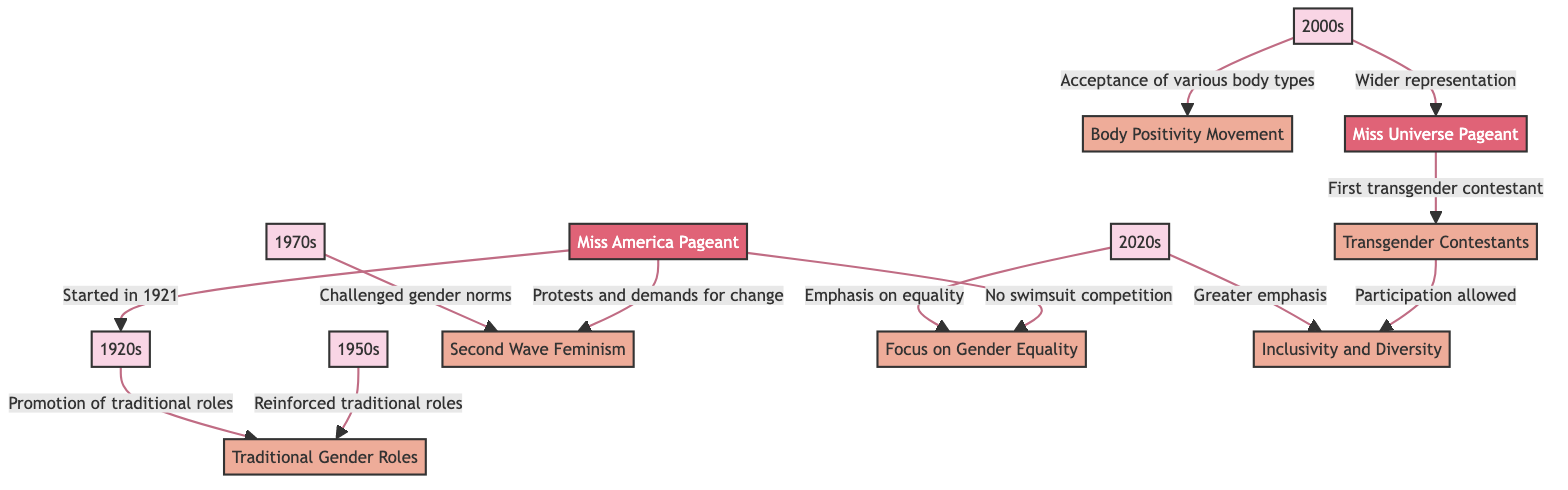What decade began the Miss America Pageant? The diagram indicates that the Miss America Pageant started in the 1920s. Therefore, the answer must refer to the decade associated with the starting event of the pageant.
Answer: 1920s Which concept is associated with the 1950s? The 1950s decade is linked to the concept of "Traditional Gender Roles," as the diagram shows a direct relationship from the 1950s to this concept denoting the reinforcement of those roles.
Answer: Traditional Gender Roles What movement challenged gender norms? According to the diagram, the 1970s is the decade connected to the "Second Wave Feminism" concept, which challenged gender norms, making this the correct association.
Answer: Second Wave Feminism How many decades are listed in the diagram? There are five distinct decades represented in the diagram: 1920s, 1950s, 1970s, 2000s, and 2020s. Therefore, by counting these, the precise number of decades can be identified.
Answer: 5 What does the 2000s emphasize in beauty pageants? The 2000s decade is illustrated in the diagram with a focus on the "Body Positivity Movement" and "Wider representation," indicating an acceptance of various body types and a broader diversity in contestants.
Answer: Body Positivity Movement, Wider representation Which pageant allowed participation of transgender contestants? The diagram specifies that the Miss Universe Pageant had the first transgender contestant, linking the pageant to the concept of inclusivity and diversity regarding representation.
Answer: Miss Universe Pageant What is emphasized in the 2020s related to gender? The 2020s decade highlights an emphasis on "Focus on Gender Equality" and "Inclusivity and Diversity," showing a clear progression in values and priorities related to gender roles in beauty pageants during this time.
Answer: Focus on Gender Equality, Inclusivity and Diversity Which decade saw protests and demands for change in pageants? The 1970s is prominently featured in the diagram as a period that witnessed protests and demands for change regarding gender roles, closely linked to the "Second Wave Feminism" concept.
Answer: 1970s Which concept is associated with transgender contestants? The direct connection in the diagram shows that 'Transgender Contestants' is interlinked with the concept of 'Inclusivity and Diversity,' indicating that this representation is a part of broader inclusivity efforts in pageants.
Answer: Inclusivity and Diversity 